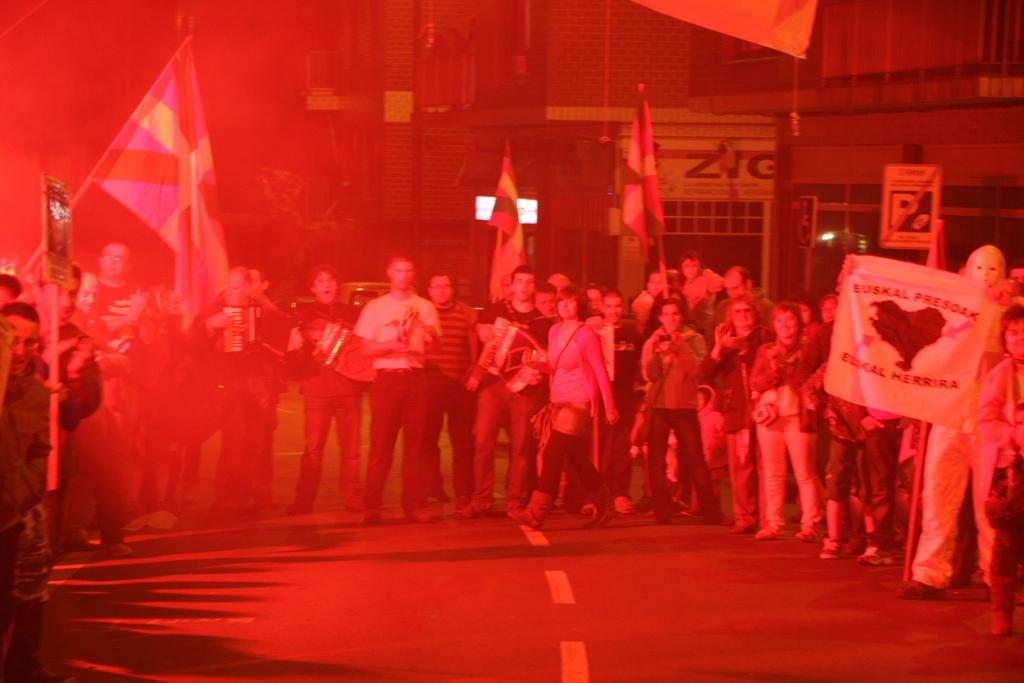What is happening in the image involving a group of people? There is a group of people in the image, and they are standing on the road. What are the people holding in the image? The people are holding flags and banners in the image. What can be seen in the background of the image? There are buildings in the background of the image. What is the red color focus light on the buildings used for? The red color focus light on the buildings is used to highlight or draw attention to the buildings. Where are the sheep located in the image? There are no sheep present in the image. What type of clover is growing on the back of the people in the image? There is no clover visible in the image, and the people are not facing the camera to show their backs. 